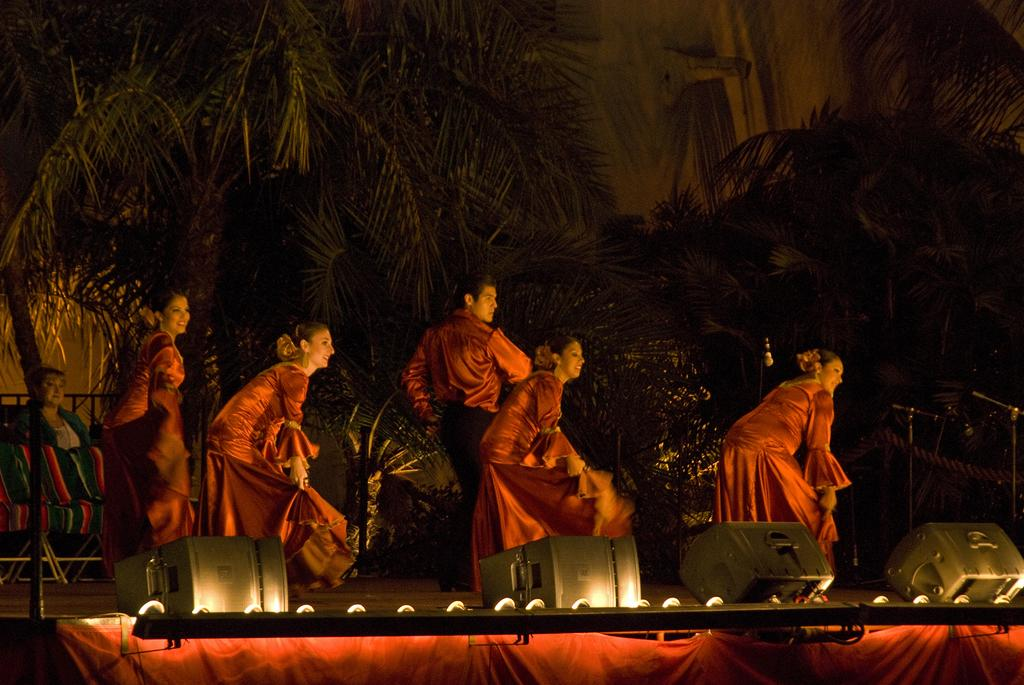What can be seen in the image in terms of human presence? There are people standing in the image. What do the people in the image have in common with regard to their clothing? All the people are wearing the same color of dress. What type of illumination is present in the image? There are lights visible in the image. What type of natural elements can be seen in the image? There are trees in the image. How many dogs are sitting next to the mailbox in the image? There are no dogs or mailbox present in the image. What type of bulb is used to light up the trees in the image? There is no information about the type of bulb used for lighting in the image, and there are no bulbs mentioned in the facts provided. 